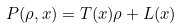Convert formula to latex. <formula><loc_0><loc_0><loc_500><loc_500>P ( \rho , x ) = T ( x ) \rho + L ( x )</formula> 